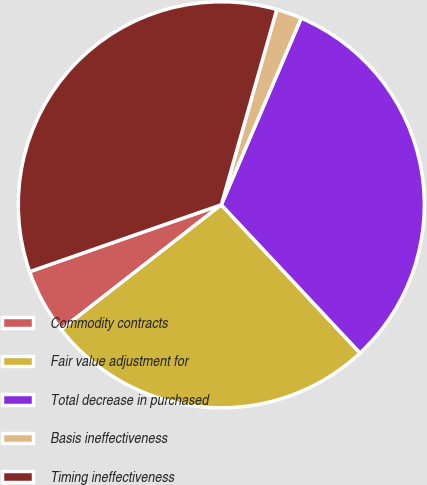<chart> <loc_0><loc_0><loc_500><loc_500><pie_chart><fcel>Commodity contracts<fcel>Fair value adjustment for<fcel>Total decrease in purchased<fcel>Basis ineffectiveness<fcel>Timing ineffectiveness<nl><fcel>5.19%<fcel>26.44%<fcel>31.59%<fcel>2.03%<fcel>34.75%<nl></chart> 